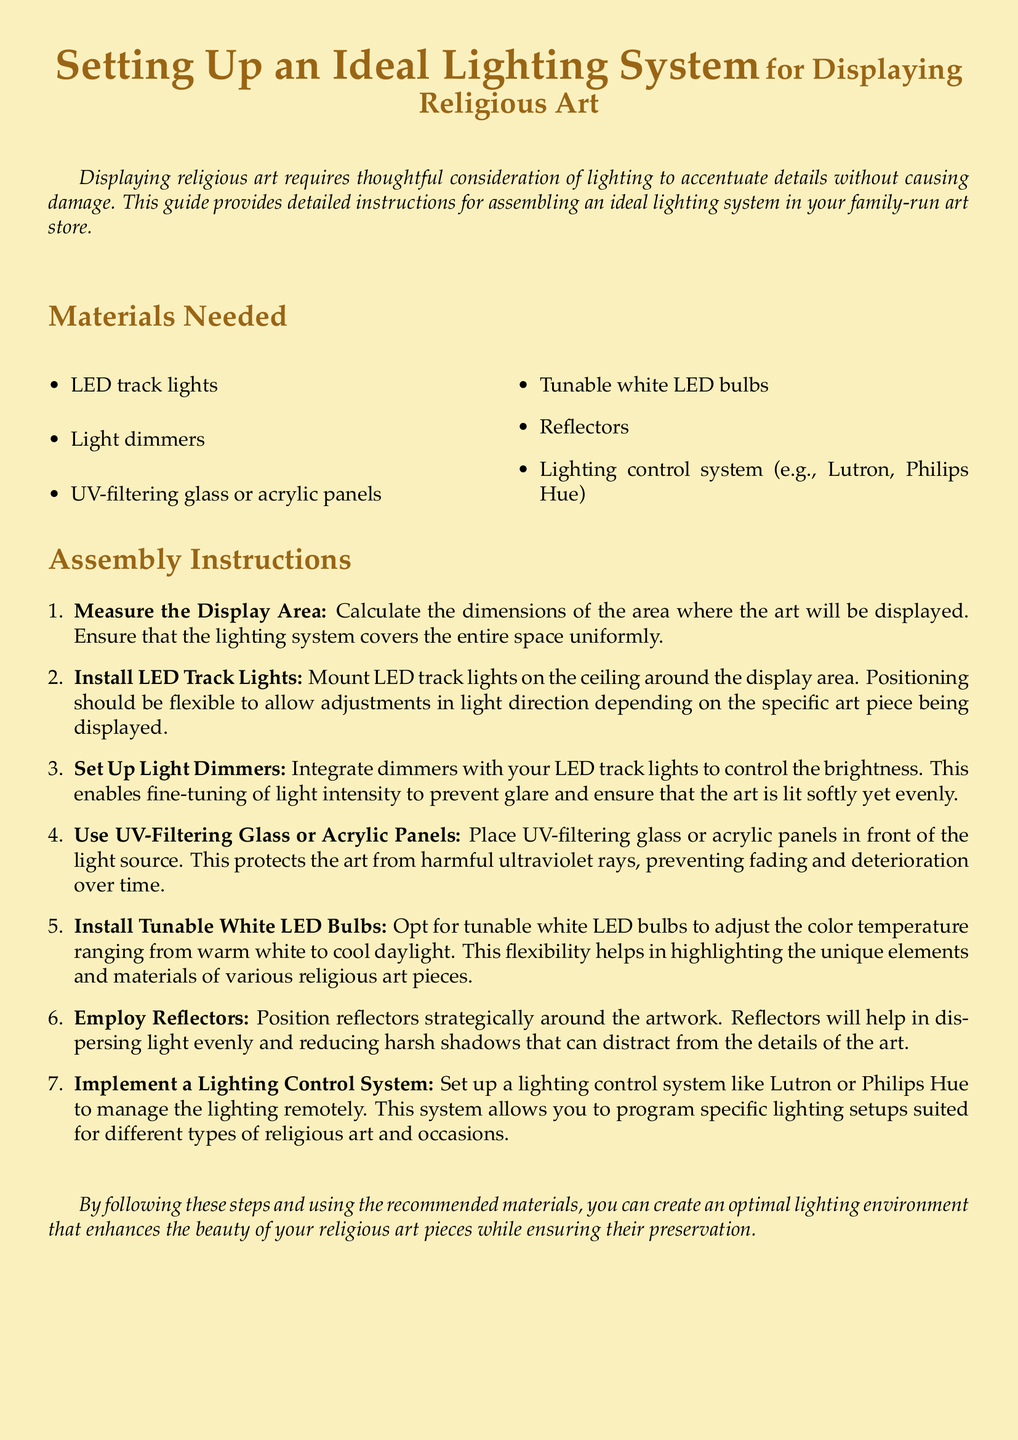What are the materials needed? The materials listed under "Materials Needed" include LED track lights, light dimmers, UV-filtering glass or acrylic panels, tunable white LED bulbs, reflectors, and a lighting control system.
Answer: LED track lights, light dimmers, UV-filtering glass or acrylic panels, tunable white LED bulbs, reflectors, lighting control system How many steps are in the assembly instructions? The number of items listed in the "Assembly Instructions" section indicates the steps provided for setting up the lighting system, which are seven.
Answer: 7 What type of bulbs should be installed? The document specifies installing tunable white LED bulbs to allow for color temperature adjustments.
Answer: Tunable white LED bulbs What is the purpose of UV-filtering panels? The document states that UV-filtering panels are used to protect art from harmful ultraviolet rays, preventing fading and deterioration.
Answer: Protects art from UV rays What control systems can be implemented? The lighting control systems mentioned include Lutron and Philips Hue for managing lighting remotely.
Answer: Lutron, Philips Hue Why is it important to use dimmers with the lights? The assembly instructions explain that dimmers allow control over brightness to prevent glare and ensure soft and even lighting.
Answer: To prevent glare and ensure soft lighting What should be done after positioning the reflectors? The document does not specifically state an action after reflectors are positioned, as they are part of a list of steps to take in the assembly.
Answer: N/A 